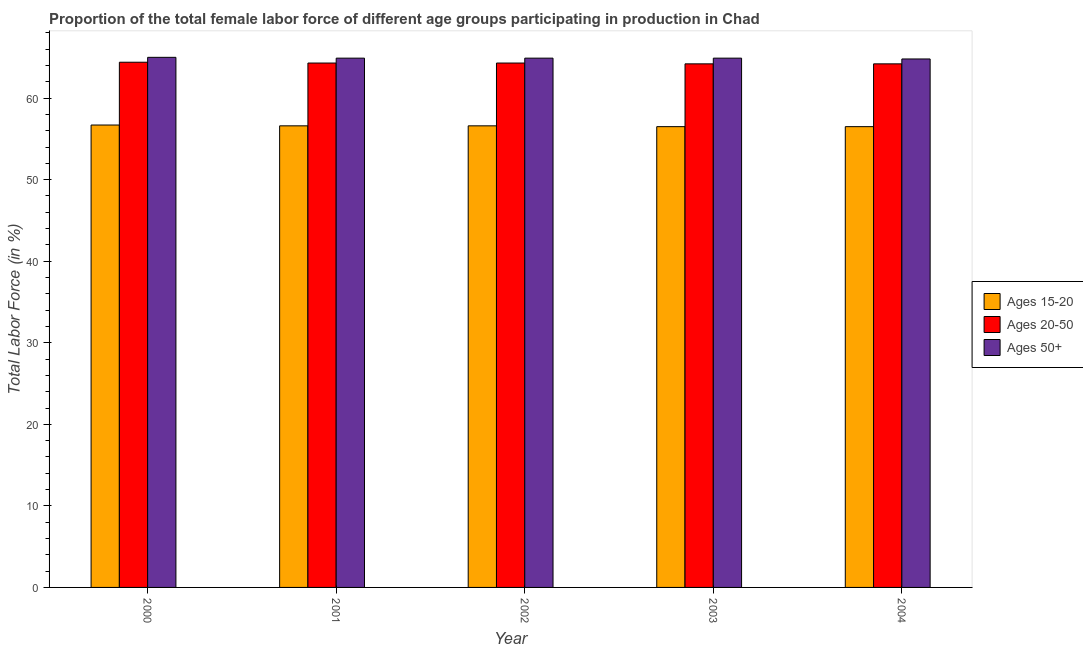How many groups of bars are there?
Ensure brevity in your answer.  5. In how many cases, is the number of bars for a given year not equal to the number of legend labels?
Make the answer very short. 0. What is the percentage of female labor force within the age group 15-20 in 2002?
Offer a very short reply. 56.6. Across all years, what is the maximum percentage of female labor force within the age group 20-50?
Keep it short and to the point. 64.4. Across all years, what is the minimum percentage of female labor force within the age group 20-50?
Your answer should be very brief. 64.2. What is the total percentage of female labor force within the age group 20-50 in the graph?
Ensure brevity in your answer.  321.4. What is the difference between the percentage of female labor force within the age group 15-20 in 2001 and that in 2003?
Keep it short and to the point. 0.1. What is the difference between the percentage of female labor force within the age group 20-50 in 2003 and the percentage of female labor force above age 50 in 2001?
Keep it short and to the point. -0.1. What is the average percentage of female labor force within the age group 15-20 per year?
Provide a short and direct response. 56.58. In the year 2004, what is the difference between the percentage of female labor force within the age group 15-20 and percentage of female labor force within the age group 20-50?
Offer a very short reply. 0. In how many years, is the percentage of female labor force above age 50 greater than 16 %?
Offer a terse response. 5. What is the ratio of the percentage of female labor force above age 50 in 2000 to that in 2002?
Offer a very short reply. 1. Is the percentage of female labor force above age 50 in 2002 less than that in 2003?
Make the answer very short. No. What is the difference between the highest and the second highest percentage of female labor force within the age group 20-50?
Offer a terse response. 0.1. What is the difference between the highest and the lowest percentage of female labor force above age 50?
Your answer should be very brief. 0.2. In how many years, is the percentage of female labor force above age 50 greater than the average percentage of female labor force above age 50 taken over all years?
Ensure brevity in your answer.  1. Is the sum of the percentage of female labor force within the age group 15-20 in 2001 and 2003 greater than the maximum percentage of female labor force within the age group 20-50 across all years?
Keep it short and to the point. Yes. What does the 3rd bar from the left in 2004 represents?
Give a very brief answer. Ages 50+. What does the 1st bar from the right in 2000 represents?
Give a very brief answer. Ages 50+. Is it the case that in every year, the sum of the percentage of female labor force within the age group 15-20 and percentage of female labor force within the age group 20-50 is greater than the percentage of female labor force above age 50?
Provide a short and direct response. Yes. How many bars are there?
Keep it short and to the point. 15. How many years are there in the graph?
Ensure brevity in your answer.  5. What is the difference between two consecutive major ticks on the Y-axis?
Keep it short and to the point. 10. Does the graph contain grids?
Ensure brevity in your answer.  No. Where does the legend appear in the graph?
Your answer should be very brief. Center right. How many legend labels are there?
Your response must be concise. 3. What is the title of the graph?
Your response must be concise. Proportion of the total female labor force of different age groups participating in production in Chad. Does "Natural Gas" appear as one of the legend labels in the graph?
Offer a very short reply. No. What is the label or title of the X-axis?
Provide a succinct answer. Year. What is the Total Labor Force (in %) in Ages 15-20 in 2000?
Offer a terse response. 56.7. What is the Total Labor Force (in %) of Ages 20-50 in 2000?
Give a very brief answer. 64.4. What is the Total Labor Force (in %) of Ages 50+ in 2000?
Your answer should be compact. 65. What is the Total Labor Force (in %) of Ages 15-20 in 2001?
Offer a very short reply. 56.6. What is the Total Labor Force (in %) in Ages 20-50 in 2001?
Provide a succinct answer. 64.3. What is the Total Labor Force (in %) of Ages 50+ in 2001?
Your response must be concise. 64.9. What is the Total Labor Force (in %) in Ages 15-20 in 2002?
Provide a succinct answer. 56.6. What is the Total Labor Force (in %) of Ages 20-50 in 2002?
Offer a very short reply. 64.3. What is the Total Labor Force (in %) in Ages 50+ in 2002?
Make the answer very short. 64.9. What is the Total Labor Force (in %) of Ages 15-20 in 2003?
Provide a short and direct response. 56.5. What is the Total Labor Force (in %) of Ages 20-50 in 2003?
Your answer should be compact. 64.2. What is the Total Labor Force (in %) in Ages 50+ in 2003?
Provide a succinct answer. 64.9. What is the Total Labor Force (in %) in Ages 15-20 in 2004?
Give a very brief answer. 56.5. What is the Total Labor Force (in %) of Ages 20-50 in 2004?
Provide a short and direct response. 64.2. What is the Total Labor Force (in %) in Ages 50+ in 2004?
Keep it short and to the point. 64.8. Across all years, what is the maximum Total Labor Force (in %) of Ages 15-20?
Offer a very short reply. 56.7. Across all years, what is the maximum Total Labor Force (in %) in Ages 20-50?
Make the answer very short. 64.4. Across all years, what is the maximum Total Labor Force (in %) of Ages 50+?
Give a very brief answer. 65. Across all years, what is the minimum Total Labor Force (in %) of Ages 15-20?
Ensure brevity in your answer.  56.5. Across all years, what is the minimum Total Labor Force (in %) in Ages 20-50?
Make the answer very short. 64.2. Across all years, what is the minimum Total Labor Force (in %) of Ages 50+?
Make the answer very short. 64.8. What is the total Total Labor Force (in %) in Ages 15-20 in the graph?
Your answer should be very brief. 282.9. What is the total Total Labor Force (in %) of Ages 20-50 in the graph?
Keep it short and to the point. 321.4. What is the total Total Labor Force (in %) in Ages 50+ in the graph?
Your response must be concise. 324.5. What is the difference between the Total Labor Force (in %) of Ages 20-50 in 2000 and that in 2001?
Offer a terse response. 0.1. What is the difference between the Total Labor Force (in %) in Ages 50+ in 2000 and that in 2001?
Offer a very short reply. 0.1. What is the difference between the Total Labor Force (in %) of Ages 50+ in 2000 and that in 2002?
Give a very brief answer. 0.1. What is the difference between the Total Labor Force (in %) of Ages 15-20 in 2000 and that in 2003?
Make the answer very short. 0.2. What is the difference between the Total Labor Force (in %) in Ages 50+ in 2000 and that in 2003?
Offer a very short reply. 0.1. What is the difference between the Total Labor Force (in %) in Ages 15-20 in 2001 and that in 2002?
Your answer should be compact. 0. What is the difference between the Total Labor Force (in %) of Ages 50+ in 2001 and that in 2003?
Provide a succinct answer. 0. What is the difference between the Total Labor Force (in %) in Ages 15-20 in 2001 and that in 2004?
Offer a terse response. 0.1. What is the difference between the Total Labor Force (in %) in Ages 20-50 in 2001 and that in 2004?
Your response must be concise. 0.1. What is the difference between the Total Labor Force (in %) in Ages 50+ in 2001 and that in 2004?
Give a very brief answer. 0.1. What is the difference between the Total Labor Force (in %) of Ages 15-20 in 2002 and that in 2003?
Offer a terse response. 0.1. What is the difference between the Total Labor Force (in %) of Ages 20-50 in 2002 and that in 2003?
Make the answer very short. 0.1. What is the difference between the Total Labor Force (in %) in Ages 50+ in 2002 and that in 2003?
Provide a succinct answer. 0. What is the difference between the Total Labor Force (in %) of Ages 15-20 in 2002 and that in 2004?
Keep it short and to the point. 0.1. What is the difference between the Total Labor Force (in %) of Ages 15-20 in 2003 and that in 2004?
Your response must be concise. 0. What is the difference between the Total Labor Force (in %) of Ages 15-20 in 2000 and the Total Labor Force (in %) of Ages 20-50 in 2002?
Your answer should be compact. -7.6. What is the difference between the Total Labor Force (in %) in Ages 20-50 in 2000 and the Total Labor Force (in %) in Ages 50+ in 2002?
Make the answer very short. -0.5. What is the difference between the Total Labor Force (in %) in Ages 20-50 in 2000 and the Total Labor Force (in %) in Ages 50+ in 2003?
Offer a terse response. -0.5. What is the difference between the Total Labor Force (in %) of Ages 15-20 in 2000 and the Total Labor Force (in %) of Ages 50+ in 2004?
Your answer should be very brief. -8.1. What is the difference between the Total Labor Force (in %) in Ages 15-20 in 2001 and the Total Labor Force (in %) in Ages 50+ in 2002?
Offer a terse response. -8.3. What is the difference between the Total Labor Force (in %) of Ages 15-20 in 2001 and the Total Labor Force (in %) of Ages 50+ in 2003?
Provide a succinct answer. -8.3. What is the difference between the Total Labor Force (in %) of Ages 20-50 in 2001 and the Total Labor Force (in %) of Ages 50+ in 2004?
Provide a short and direct response. -0.5. What is the difference between the Total Labor Force (in %) of Ages 15-20 in 2002 and the Total Labor Force (in %) of Ages 50+ in 2003?
Provide a short and direct response. -8.3. What is the difference between the Total Labor Force (in %) of Ages 20-50 in 2002 and the Total Labor Force (in %) of Ages 50+ in 2003?
Make the answer very short. -0.6. What is the difference between the Total Labor Force (in %) of Ages 15-20 in 2002 and the Total Labor Force (in %) of Ages 50+ in 2004?
Provide a short and direct response. -8.2. What is the difference between the Total Labor Force (in %) of Ages 15-20 in 2003 and the Total Labor Force (in %) of Ages 50+ in 2004?
Keep it short and to the point. -8.3. What is the difference between the Total Labor Force (in %) in Ages 20-50 in 2003 and the Total Labor Force (in %) in Ages 50+ in 2004?
Provide a succinct answer. -0.6. What is the average Total Labor Force (in %) of Ages 15-20 per year?
Provide a succinct answer. 56.58. What is the average Total Labor Force (in %) in Ages 20-50 per year?
Make the answer very short. 64.28. What is the average Total Labor Force (in %) in Ages 50+ per year?
Provide a short and direct response. 64.9. In the year 2000, what is the difference between the Total Labor Force (in %) of Ages 15-20 and Total Labor Force (in %) of Ages 20-50?
Give a very brief answer. -7.7. In the year 2000, what is the difference between the Total Labor Force (in %) of Ages 15-20 and Total Labor Force (in %) of Ages 50+?
Give a very brief answer. -8.3. In the year 2000, what is the difference between the Total Labor Force (in %) in Ages 20-50 and Total Labor Force (in %) in Ages 50+?
Your answer should be compact. -0.6. In the year 2002, what is the difference between the Total Labor Force (in %) of Ages 15-20 and Total Labor Force (in %) of Ages 20-50?
Offer a terse response. -7.7. In the year 2002, what is the difference between the Total Labor Force (in %) in Ages 15-20 and Total Labor Force (in %) in Ages 50+?
Your response must be concise. -8.3. In the year 2003, what is the difference between the Total Labor Force (in %) of Ages 15-20 and Total Labor Force (in %) of Ages 20-50?
Your answer should be compact. -7.7. In the year 2003, what is the difference between the Total Labor Force (in %) in Ages 15-20 and Total Labor Force (in %) in Ages 50+?
Give a very brief answer. -8.4. In the year 2004, what is the difference between the Total Labor Force (in %) in Ages 15-20 and Total Labor Force (in %) in Ages 20-50?
Provide a short and direct response. -7.7. In the year 2004, what is the difference between the Total Labor Force (in %) of Ages 15-20 and Total Labor Force (in %) of Ages 50+?
Offer a terse response. -8.3. What is the ratio of the Total Labor Force (in %) in Ages 15-20 in 2000 to that in 2001?
Your answer should be very brief. 1. What is the ratio of the Total Labor Force (in %) of Ages 20-50 in 2000 to that in 2001?
Your answer should be very brief. 1. What is the ratio of the Total Labor Force (in %) in Ages 50+ in 2000 to that in 2001?
Offer a very short reply. 1. What is the ratio of the Total Labor Force (in %) of Ages 15-20 in 2000 to that in 2002?
Offer a terse response. 1. What is the ratio of the Total Labor Force (in %) in Ages 20-50 in 2000 to that in 2002?
Your response must be concise. 1. What is the ratio of the Total Labor Force (in %) of Ages 50+ in 2000 to that in 2002?
Your answer should be very brief. 1. What is the ratio of the Total Labor Force (in %) in Ages 15-20 in 2000 to that in 2003?
Provide a succinct answer. 1. What is the ratio of the Total Labor Force (in %) in Ages 20-50 in 2000 to that in 2003?
Make the answer very short. 1. What is the ratio of the Total Labor Force (in %) in Ages 50+ in 2000 to that in 2003?
Ensure brevity in your answer.  1. What is the ratio of the Total Labor Force (in %) of Ages 50+ in 2000 to that in 2004?
Provide a short and direct response. 1. What is the ratio of the Total Labor Force (in %) of Ages 15-20 in 2001 to that in 2002?
Provide a succinct answer. 1. What is the ratio of the Total Labor Force (in %) in Ages 20-50 in 2001 to that in 2002?
Your answer should be very brief. 1. What is the ratio of the Total Labor Force (in %) of Ages 15-20 in 2001 to that in 2003?
Your response must be concise. 1. What is the ratio of the Total Labor Force (in %) of Ages 20-50 in 2001 to that in 2003?
Your response must be concise. 1. What is the ratio of the Total Labor Force (in %) in Ages 50+ in 2001 to that in 2004?
Keep it short and to the point. 1. What is the ratio of the Total Labor Force (in %) of Ages 15-20 in 2002 to that in 2003?
Make the answer very short. 1. What is the ratio of the Total Labor Force (in %) of Ages 20-50 in 2002 to that in 2003?
Give a very brief answer. 1. What is the ratio of the Total Labor Force (in %) in Ages 50+ in 2002 to that in 2003?
Your answer should be compact. 1. What is the ratio of the Total Labor Force (in %) in Ages 15-20 in 2002 to that in 2004?
Give a very brief answer. 1. What is the ratio of the Total Labor Force (in %) in Ages 15-20 in 2003 to that in 2004?
Make the answer very short. 1. What is the ratio of the Total Labor Force (in %) in Ages 50+ in 2003 to that in 2004?
Your response must be concise. 1. What is the difference between the highest and the second highest Total Labor Force (in %) in Ages 15-20?
Make the answer very short. 0.1. 